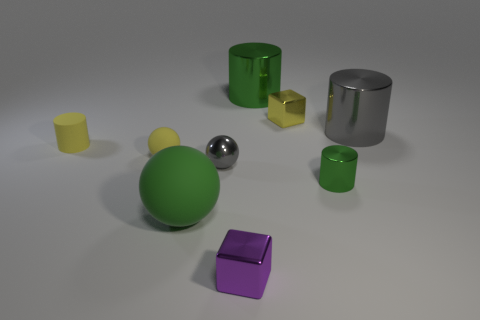There is a large ball; is it the same color as the tiny metallic cube behind the large green matte sphere?
Your answer should be very brief. No. What number of other objects are there of the same material as the tiny yellow cube?
Your response must be concise. 5. Are there more big green objects than tiny brown matte things?
Provide a succinct answer. Yes. Does the big matte ball that is on the right side of the matte cylinder have the same color as the shiny ball?
Give a very brief answer. No. The large ball has what color?
Keep it short and to the point. Green. There is a gray shiny object that is on the right side of the purple metallic object; is there a metal cube that is behind it?
Your answer should be very brief. Yes. What shape is the gray thing to the right of the green shiny thing in front of the big green shiny cylinder?
Provide a succinct answer. Cylinder. Are there fewer tiny rubber things than large green cylinders?
Your response must be concise. No. Are the big gray object and the tiny gray sphere made of the same material?
Offer a very short reply. Yes. There is a large thing that is to the left of the tiny green metal cylinder and behind the small yellow ball; what is its color?
Offer a terse response. Green. 